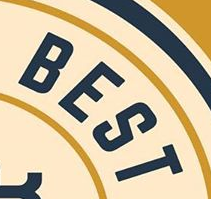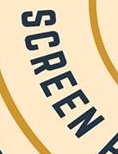Read the text from these images in sequence, separated by a semicolon. BEST; SCREEN 